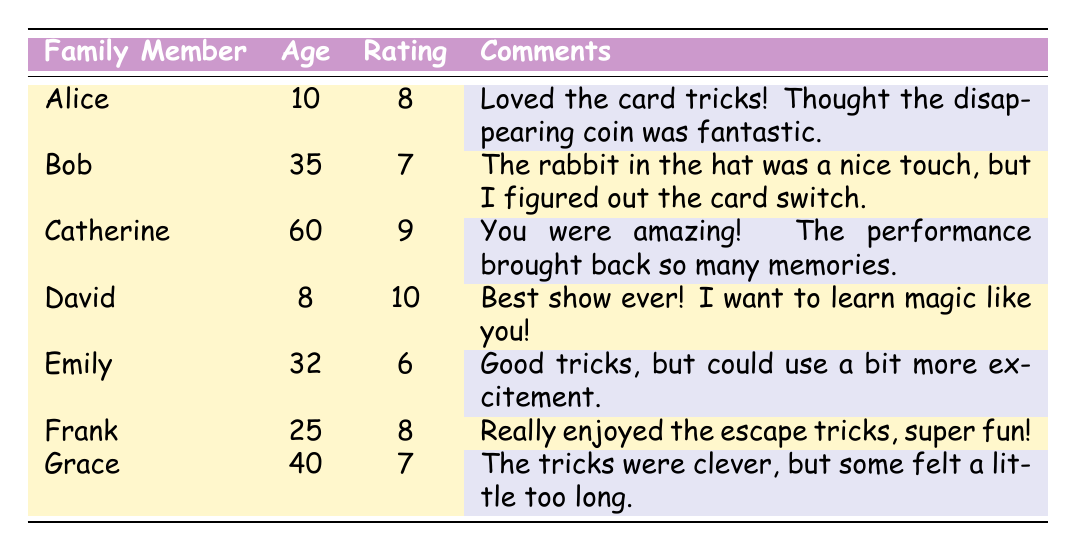What is David's rating for the magic trick performance? David's rating is found in the Ratings column, and it states he has a rating of 10.
Answer: 10 Which family member provided the highest rating? The ratings are compared, and David has the highest rating of 10.
Answer: David How many family members rated the performance above 7? The ratings above 7 are 8 (Alice), 9 (Catherine), and 10 (David), giving a total of 3 family members.
Answer: 3 What was the average rating of the magic trick performances? The ratings are 8, 7, 9, 10, 6, 8, and 7. Summing these ratings gives 55, and there are 7 family members, so the average is 55/7 = 7.86.
Answer: 7.86 Did Emily enjoy the magic tricks according to her comments? Emily's rating is 6, and her comment indicates that while the tricks were good, she felt they needed more excitement, suggesting she didn't fully enjoy them.
Answer: No Which family member is the oldest, and what is their rating? By examining the Age column, Catherine is the oldest at 60 years old with a rating of 9.
Answer: Catherine, 9 What is the difference between the highest and lowest ratings? The highest rating is 10 (David), and the lowest is 6 (Emily). The difference is 10 - 6 = 4.
Answer: 4 What did Alice think about the disappearing coin trick? In her comments, Alice explicitly stated that she thought the disappearing coin was fantastic.
Answer: Fantastic Are any family members aged 30 or older giving a rating of less than 7? Emily (32 years old) rated the performance a 6, which is less than 7, confirming that there is at least one member meeting this criterion.
Answer: Yes 